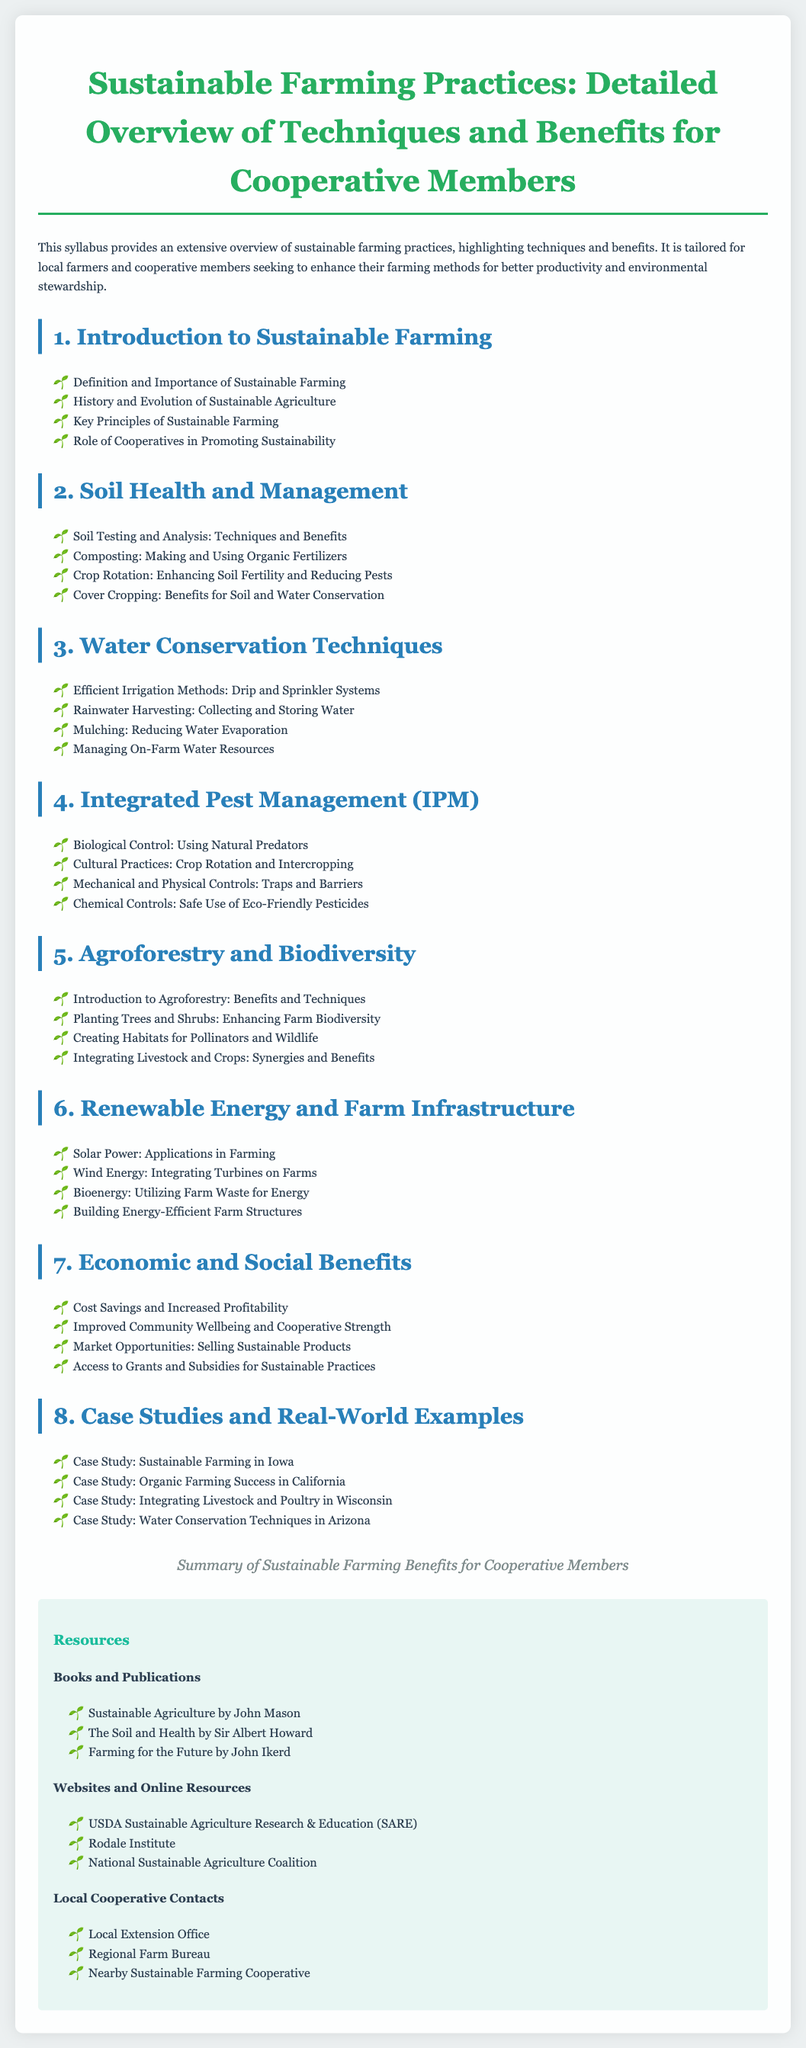what is the title of the syllabus? The title is clearly stated at the top of the document under the main heading.
Answer: Sustainable Farming Practices: Detailed Overview of Techniques and Benefits for Cooperative Members how many sections are in the syllabus? The number of sections can be counted from the headers listed in the document.
Answer: Eight what are the two types of irrigation methods mentioned? The document lists specific irrigation methods under the water conservation techniques section.
Answer: Drip and Sprinkler Systems which topic covers the use of natural predators for pest control? This can be found in the Integrated Pest Management section of the syllabus.
Answer: Biological Control what is one benefit of cover cropping? Benefits are outlined in the Soil Health and Management section.
Answer: Benefits for Soil and Water Conservation name one resource listed in the Local Cooperative Contacts section. Resources are provided at the end of the syllabus under the relevant headings.
Answer: Local Extension Office how many case studies are presented in the syllabus? The number of case studies can be identified by counting the listed items in the respective section.
Answer: Four what is one economic benefit mentioned for cooperative members? This information can be retrieved from the Economic and Social Benefits section.
Answer: Increased Profitability 